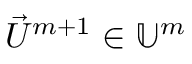Convert formula to latex. <formula><loc_0><loc_0><loc_500><loc_500>\vec { U } ^ { m + 1 } \in \mathbb { U } ^ { m }</formula> 